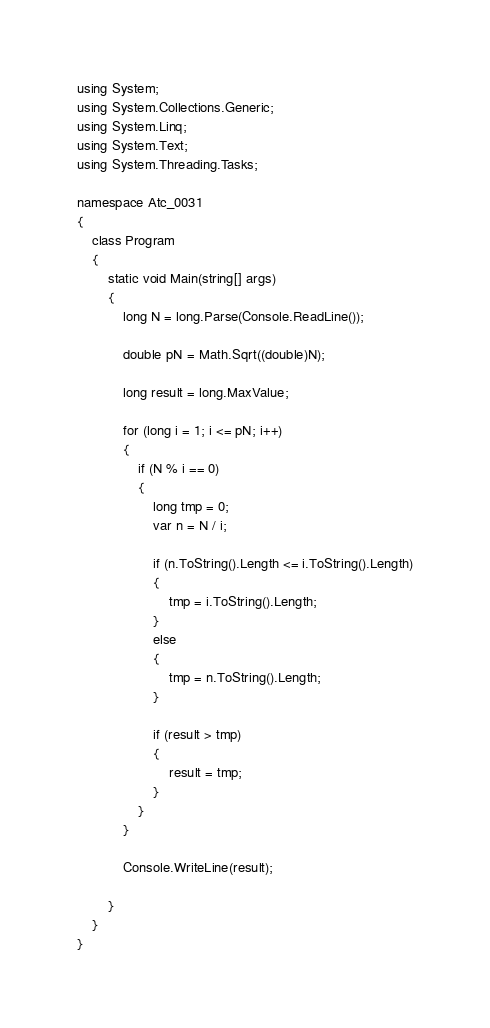<code> <loc_0><loc_0><loc_500><loc_500><_C#_>using System;
using System.Collections.Generic;
using System.Linq;
using System.Text;
using System.Threading.Tasks;

namespace Atc_0031
{
    class Program
    {
        static void Main(string[] args)
        {
            long N = long.Parse(Console.ReadLine());

            double pN = Math.Sqrt((double)N);

            long result = long.MaxValue;

            for (long i = 1; i <= pN; i++)
            {
                if (N % i == 0)
                {
                    long tmp = 0;
                    var n = N / i;

                    if (n.ToString().Length <= i.ToString().Length)
                    {
                        tmp = i.ToString().Length;
                    }
                    else
                    {
                        tmp = n.ToString().Length;
                    }

                    if (result > tmp)
                    {
                        result = tmp;
                    }
                }
            }

            Console.WriteLine(result);

        }
    }
}
</code> 